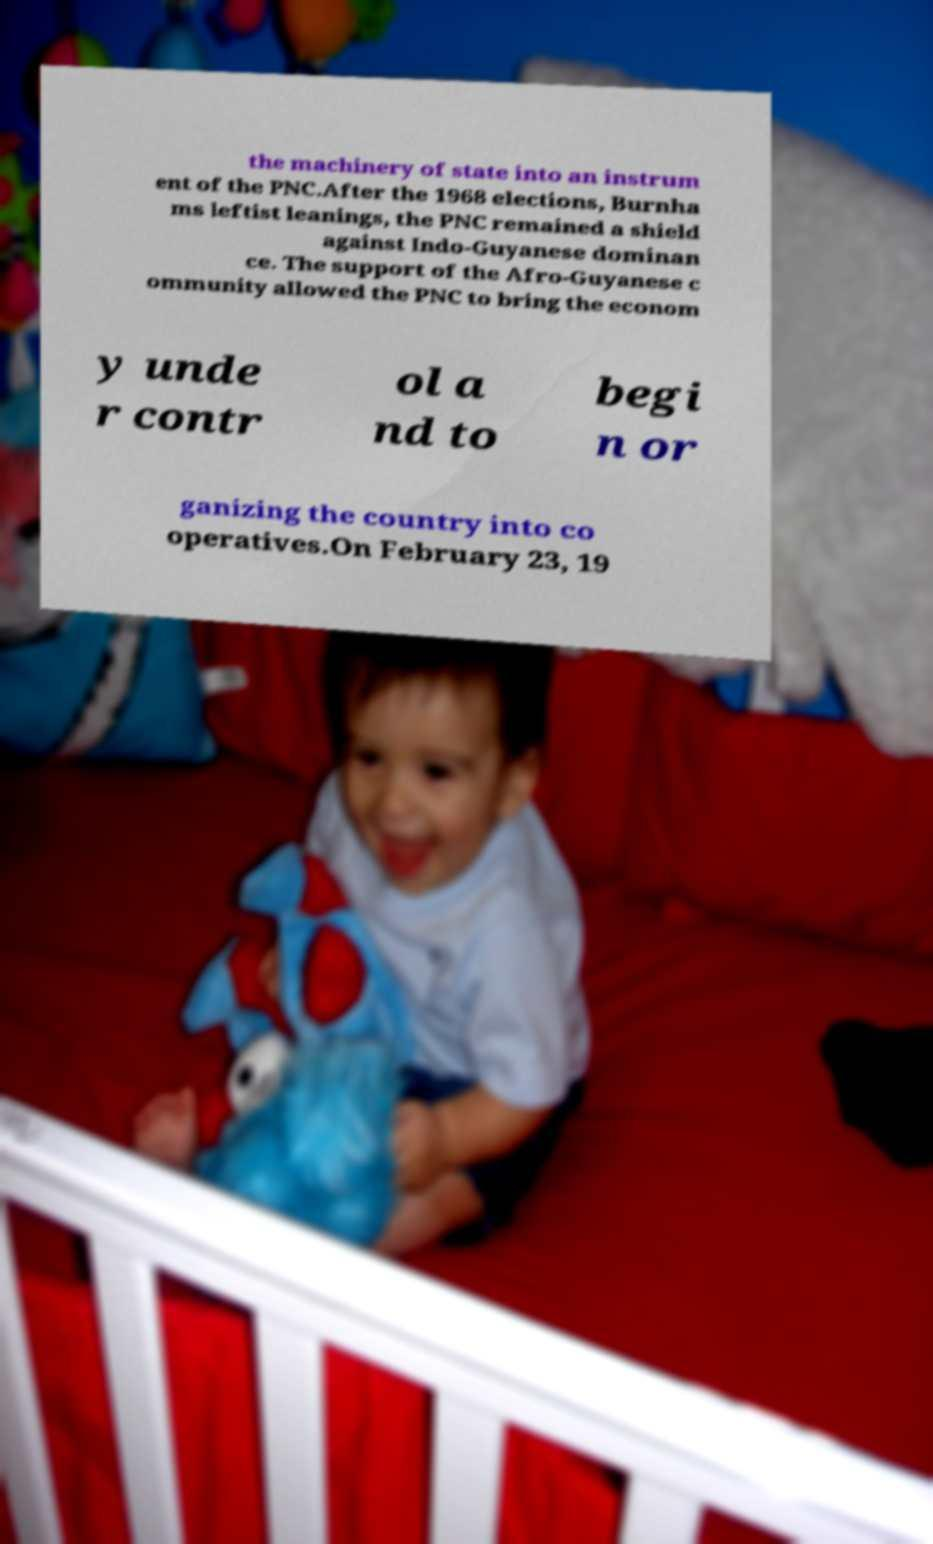What messages or text are displayed in this image? I need them in a readable, typed format. the machinery of state into an instrum ent of the PNC.After the 1968 elections, Burnha ms leftist leanings, the PNC remained a shield against Indo-Guyanese dominan ce. The support of the Afro-Guyanese c ommunity allowed the PNC to bring the econom y unde r contr ol a nd to begi n or ganizing the country into co operatives.On February 23, 19 